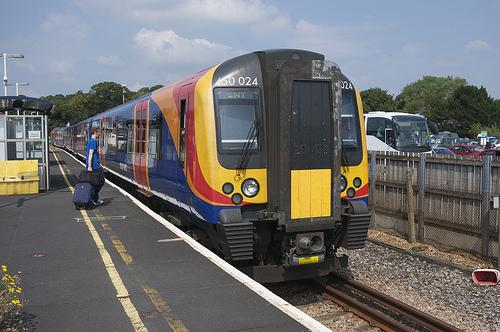Give information about the front part of the train. The windscreen of the train is visible, the train's number is 50,024, and the headlights are round. What else is on the platform besides the man and the train? There are street lights on the platform, white line along the edge of the platform, and yellow flowers. Describe the man and his belongings in the image. The man is wearing a blue shirt and carrying two suitcases, one black and one blue. Explain the weather conditions in the image. A sunny blue day with a really cloudy sky. What type of fence can be seen in the image? A worn wooden fence located along the railway track. Describe the tracks where the train is stationed. Train tracks are next to a sidewalk with track ballast and rocks around them. Identify the type of train present in the image. A busy commuter train with multiple colors, such as yellow, red, orange, and blue. What can be seen next to the railway track? Train tracks are surrounded by rocks, and there is a wooden fence along the track. What type of transport can be seen behind the fence? A passenger bus dropping off passengers can be seen behind the fence. Comment on the road visible in the image. A road with tarmac has yellow lines painted on the pavement. 